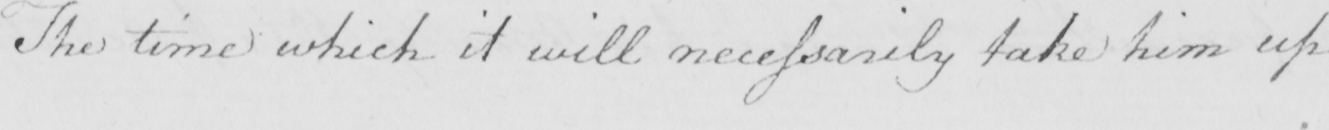What is written in this line of handwriting? The time which it will necessarily take him up 